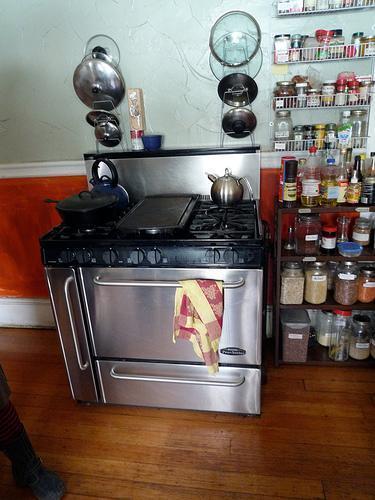How many bottles are there?
Give a very brief answer. 1. 